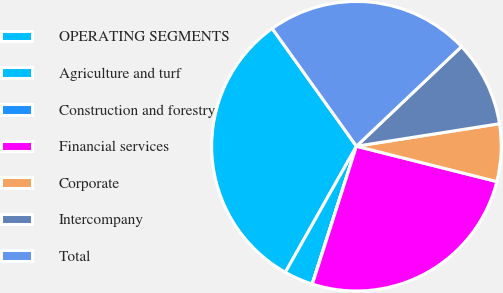Convert chart. <chart><loc_0><loc_0><loc_500><loc_500><pie_chart><fcel>OPERATING SEGMENTS<fcel>Agriculture and turf<fcel>Construction and forestry<fcel>Financial services<fcel>Corporate<fcel>Intercompany<fcel>Total<nl><fcel>31.94%<fcel>3.22%<fcel>0.03%<fcel>25.99%<fcel>6.41%<fcel>9.6%<fcel>22.8%<nl></chart> 